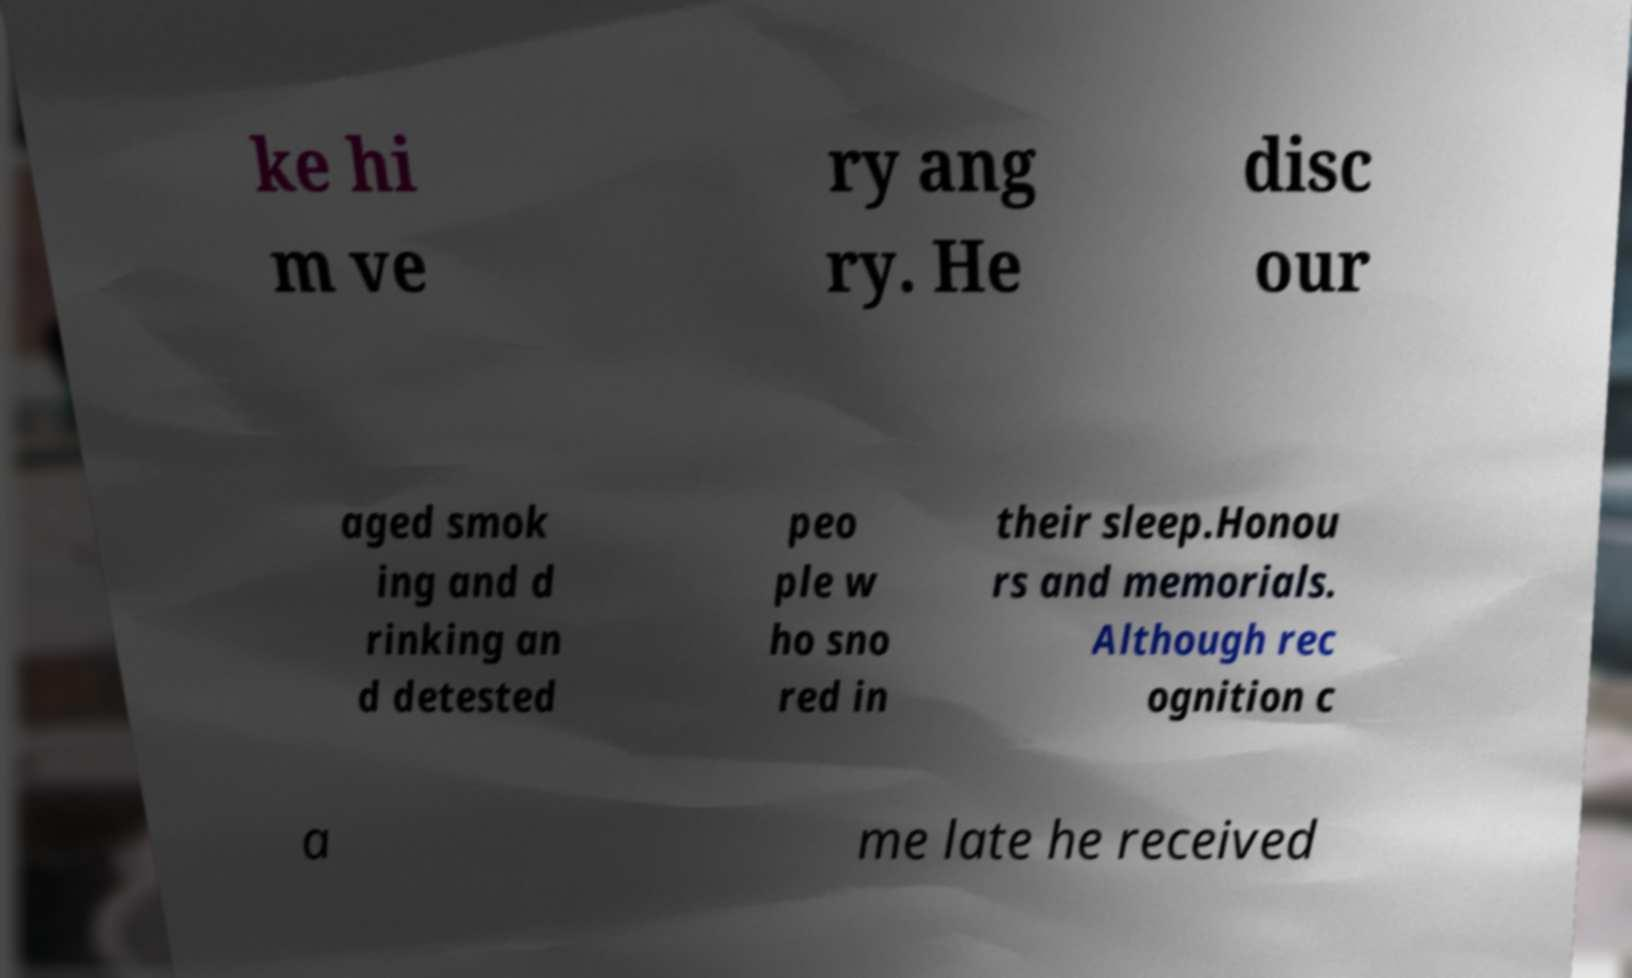Can you accurately transcribe the text from the provided image for me? ke hi m ve ry ang ry. He disc our aged smok ing and d rinking an d detested peo ple w ho sno red in their sleep.Honou rs and memorials. Although rec ognition c a me late he received 